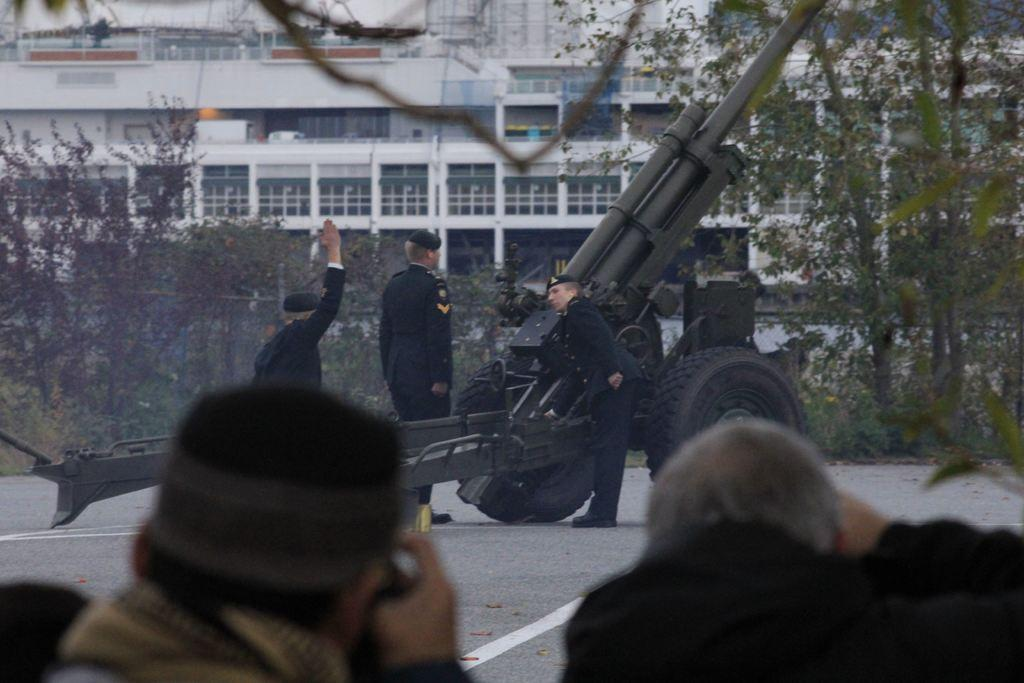How many people are present in the image? There are two people in the image. What is located in front of the two people? There is a howitzer in front of the two people. Can you describe the scene on the road? There are three people on the road. What can be seen in the background of the image? There are trees, a building, and some unspecified objects in the background of the image. What type of curtain is hanging in the background of the image? There is no curtain present in the image; it features a howitzer in front of two people, three people on the road, and a background with trees, a building, and unspecified objects. 